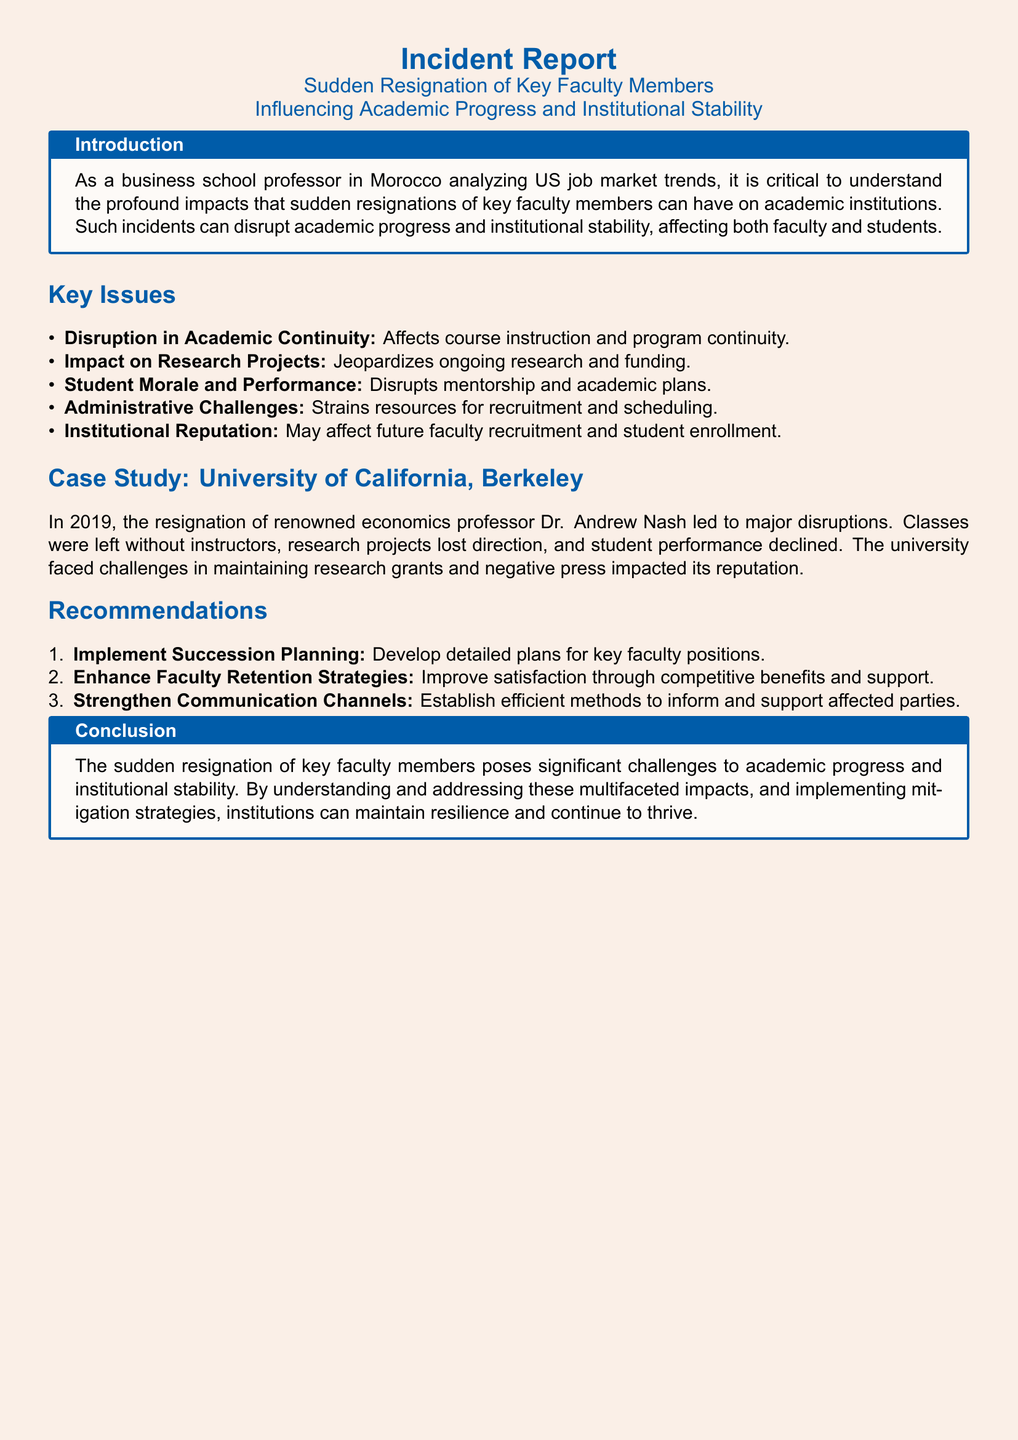What is the title of the incident report? The title of the incident report is found at the top of the document, stating the subject and focus of the report.
Answer: Sudden Resignation of Key Faculty Members Influencing Academic Progress and Institutional Stability Who was the key faculty member mentioned in the case study? The case study provides a specific example and names the professor whose resignation caused disruptions at the institution.
Answer: Dr. Andrew Nash In what year did the resignation of the key faculty member occur at the University of California, Berkeley? The document specifies the year of the incident in the case study section for clarity and timeline reference.
Answer: 2019 What is one of the key issues identified related to faculty resignations? The document outlines several issues, indicating disruption and its effect on educational processes among other areas.
Answer: Disruption in Academic Continuity What does the report recommend to improve faculty retention? The recommendations section includes strategies to enhance faculty satisfaction and reduce turnover.
Answer: Enhance Faculty Retention Strategies What impact did the resignation have on student performance according to the report? The document describes the consequences on students as mentioned in the key issues section, emphasizing the adverse effects.
Answer: Declined What is one strategy recommended for addressing administrative challenges? The recommendations provide specific steps that institutions can take to mitigate the effects of faculty resignations on operations.
Answer: Strengthen Communication Channels Which university was used as a case study in the document? The document names the institution highlighted in the specific case study to illustrate the issues discussed.
Answer: University of California, Berkeley What is the primary focus of the introduction section in the report? The introduction explicates the broader context and significance of studying faculty resignations within academia.
Answer: Impacts on academic institutions 